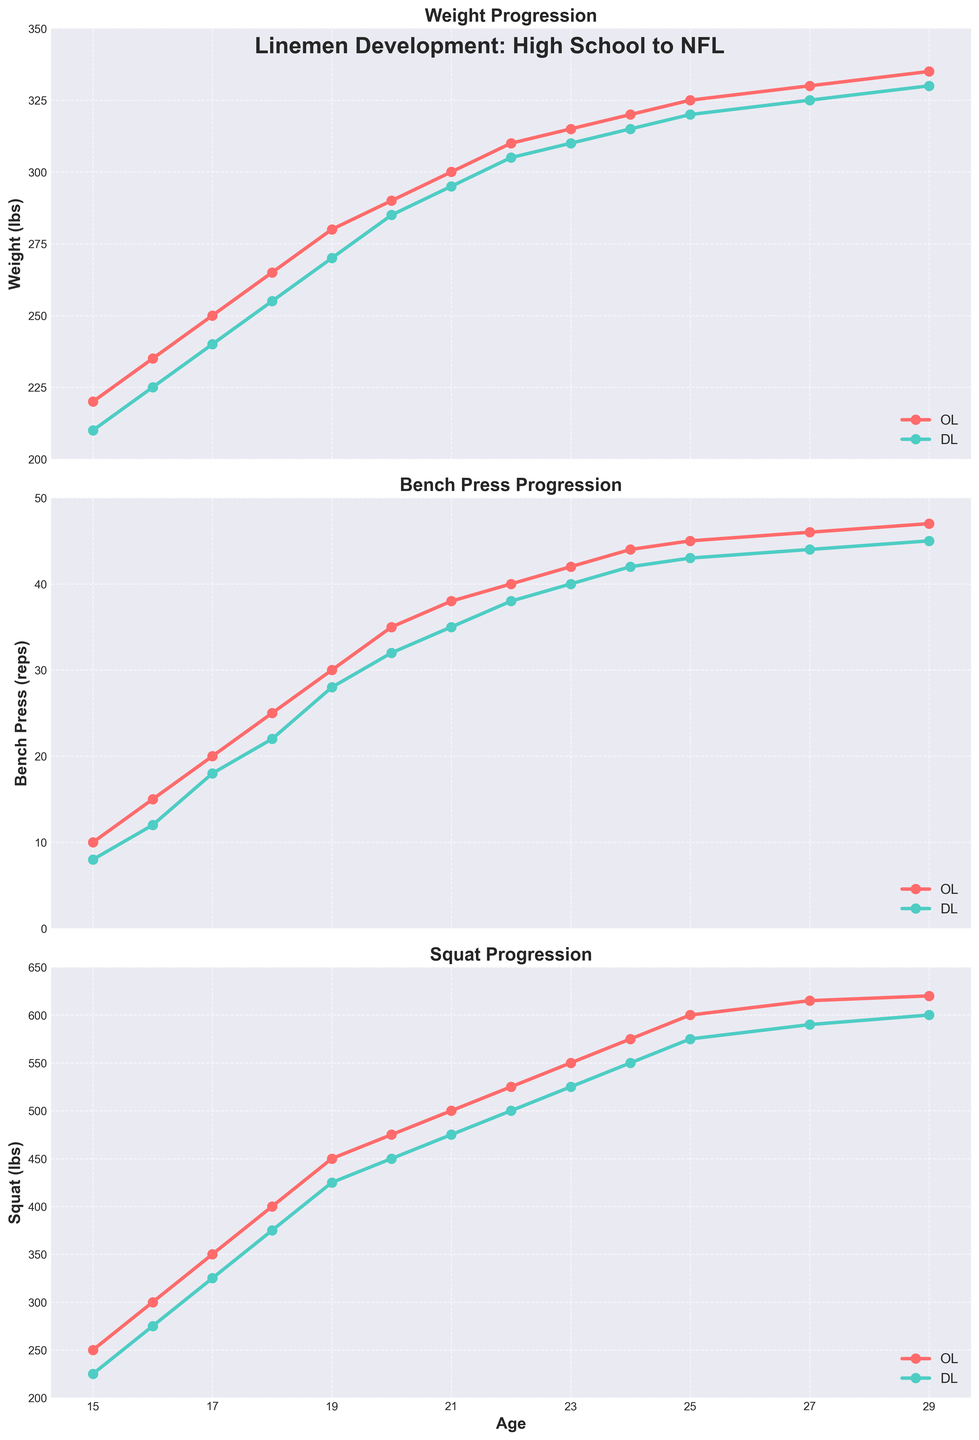What's the weight difference between a High School OL at age 15 and an NFL OL at age 29? The weight of a High School OL at age 15 is 220 lbs, and the weight of an NFL OL at age 29 is 335 lbs. Subtract 220 lbs from 335 lbs to get the weight difference: 335 - 220 = 115 lbs
Answer: 115 lbs Which position, OL or DL, shows a greater increase in bench press reps from high school senior to NFL rookie? A high school senior OL benches 25 reps, and an NFL rookie OL benches 42 reps, an increase of 42 - 25 = 17 reps. A high school senior DL benches 22 reps, and an NFL rookie DL benches 40 reps, an increase of 40 - 22 = 18 reps.
Answer: DL At what age does the OL's squat surpass 500 lbs? From the chart, we can see that the OL's squat surpasses 500 lbs at age 21, during their junior year in college (squat is 500 lbs at age 21).
Answer: 21 How much do both positions (OL and DL) bench press at age 24? The chart shows that at age 24, OL bench presses 44 reps and DL bench presses 42 reps.
Answer: OL: 44 reps, DL: 42 reps Which metric shows the biggest percentage increase from high school to the NFL for both OL and DL? For OL: Weight increases from 220 lbs to 335 lbs (335 - 220)/220 * 100% = 52.27%, bench press increases from 10 reps to 47 reps (47 - 10)/10 * 100% = 370%, squat increases from 250 lbs to 620 lbs (620 - 250)/250 * 100% = 148%. Bench press has the highest increase for OL. For DL: Weight increases from 210 lbs to 330 lbs (330 - 210)/210 * 100% = 57.14%, bench press increases from 8 reps to 45 reps (45 - 8)/8 * 100% = 462.5%, squat increases from 225 lbs to 600 lbs (600 - 225)/225 * 100% = 166.67%. Bench press has the highest increase for DL.
Answer: Bench press Which position has a higher maximum squat? By examining the squat progression lines, the DL has a maximum squat of 600 lbs, while the OL has a maximum squat of 620 lbs.
Answer: OL What is the average weight of a College Junior OL and DL? The weight of a College Junior OL is 300 lbs, and the weight of a College Junior DL is 295 lbs. The average weight is (300 + 295) / 2 = 297.5 lbs
Answer: 297.5 lbs Describe the trend in bench press progression from high school to NFL for the OL position. The OL position shows a steady increase in bench press reps from high school (10 reps) to NFL (47 reps), indicating continuous strength improvement over time.
Answer: Steady increase At what ages do both OL and DL reach their peak squat performance? The OL reaches peak squat performance at age 29 with 620 lbs, and the DL reaches peak squat performance at age 29 with 600 lbs, as shown in their respective squat progression lines.
Answer: Age 29 